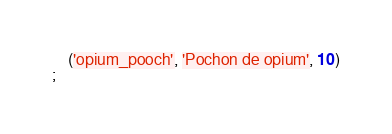Convert code to text. <code><loc_0><loc_0><loc_500><loc_500><_SQL_>	('opium_pooch', 'Pochon de opium', 10)
;</code> 